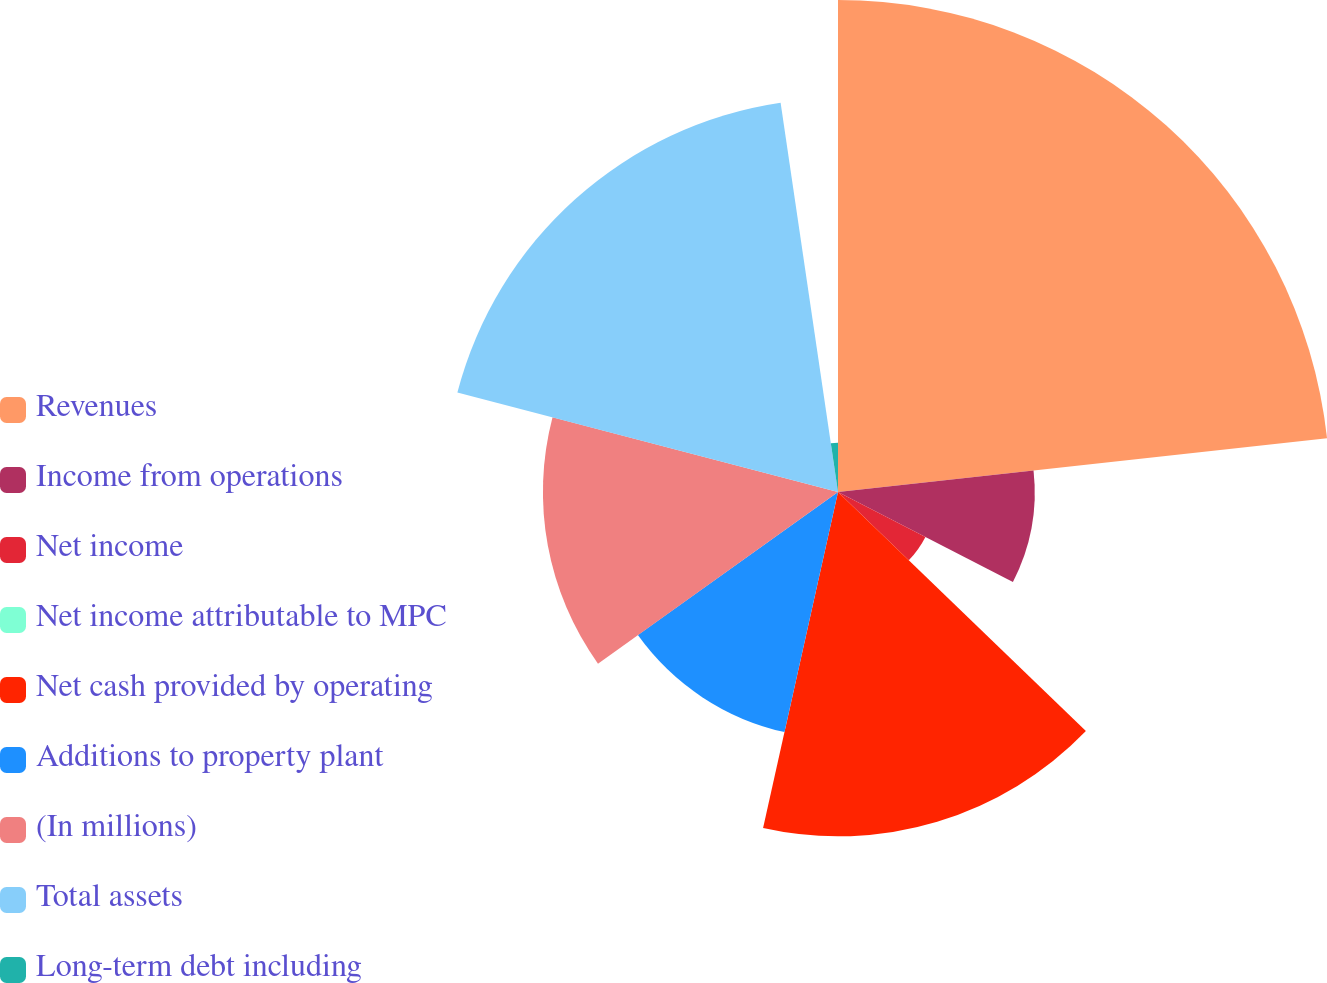Convert chart to OTSL. <chart><loc_0><loc_0><loc_500><loc_500><pie_chart><fcel>Revenues<fcel>Income from operations<fcel>Net income<fcel>Net income attributable to MPC<fcel>Net cash provided by operating<fcel>Additions to property plant<fcel>(In millions)<fcel>Total assets<fcel>Long-term debt including<nl><fcel>23.26%<fcel>9.3%<fcel>4.65%<fcel>0.0%<fcel>16.28%<fcel>11.63%<fcel>13.95%<fcel>18.6%<fcel>2.33%<nl></chart> 